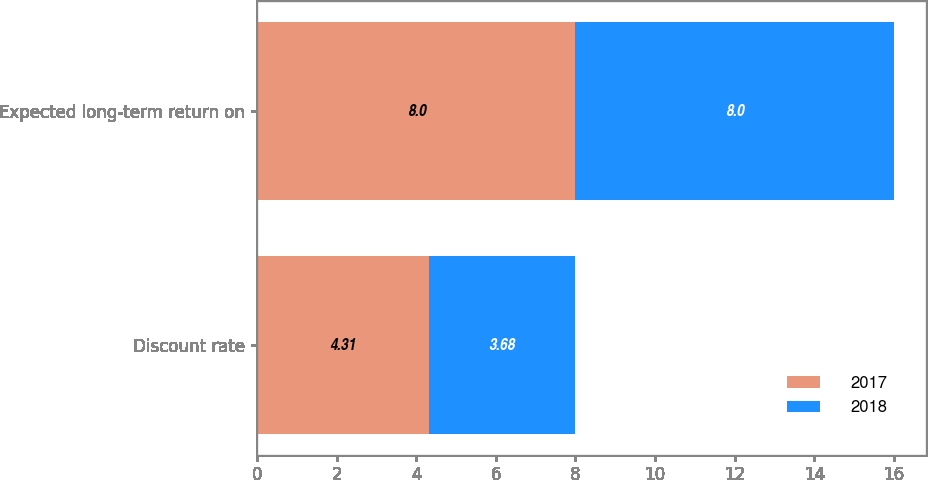<chart> <loc_0><loc_0><loc_500><loc_500><stacked_bar_chart><ecel><fcel>Discount rate<fcel>Expected long-term return on<nl><fcel>2017<fcel>4.31<fcel>8<nl><fcel>2018<fcel>3.68<fcel>8<nl></chart> 